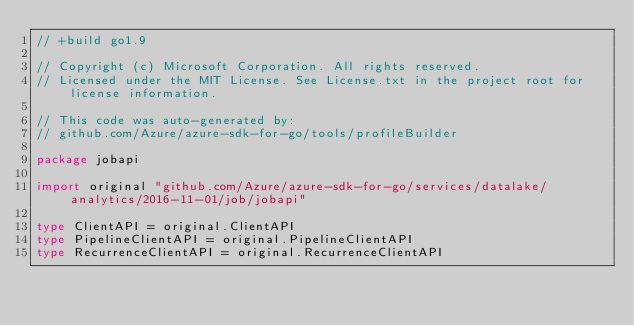Convert code to text. <code><loc_0><loc_0><loc_500><loc_500><_Go_>// +build go1.9

// Copyright (c) Microsoft Corporation. All rights reserved.
// Licensed under the MIT License. See License.txt in the project root for license information.

// This code was auto-generated by:
// github.com/Azure/azure-sdk-for-go/tools/profileBuilder

package jobapi

import original "github.com/Azure/azure-sdk-for-go/services/datalake/analytics/2016-11-01/job/jobapi"

type ClientAPI = original.ClientAPI
type PipelineClientAPI = original.PipelineClientAPI
type RecurrenceClientAPI = original.RecurrenceClientAPI
</code> 